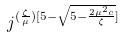Convert formula to latex. <formula><loc_0><loc_0><loc_500><loc_500>j ^ { ( \frac { \zeta } { \mu } ) [ 5 - \sqrt { 5 - \frac { 2 \mu ^ { 2 } c } { \zeta } } ] }</formula> 